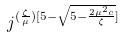Convert formula to latex. <formula><loc_0><loc_0><loc_500><loc_500>j ^ { ( \frac { \zeta } { \mu } ) [ 5 - \sqrt { 5 - \frac { 2 \mu ^ { 2 } c } { \zeta } } ] }</formula> 